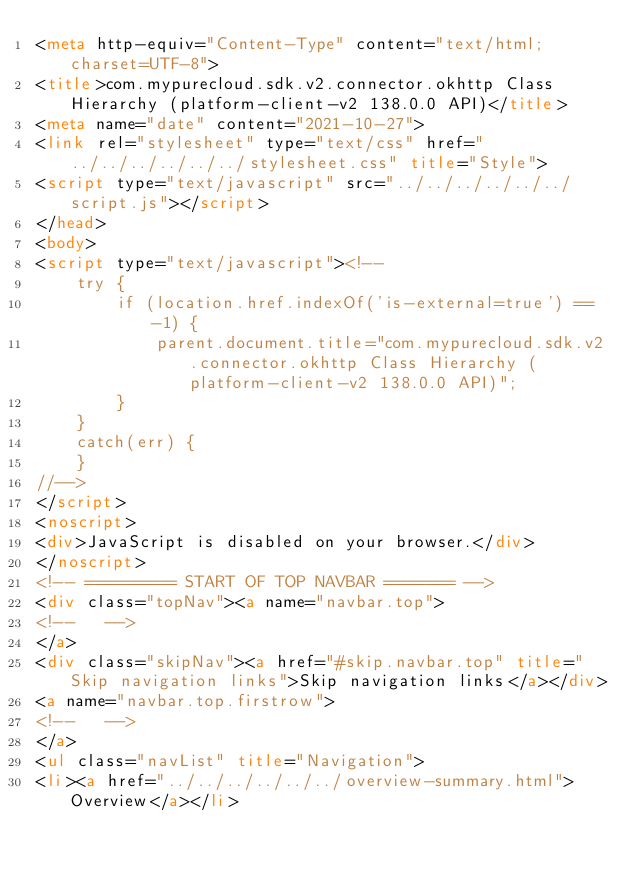<code> <loc_0><loc_0><loc_500><loc_500><_HTML_><meta http-equiv="Content-Type" content="text/html; charset=UTF-8">
<title>com.mypurecloud.sdk.v2.connector.okhttp Class Hierarchy (platform-client-v2 138.0.0 API)</title>
<meta name="date" content="2021-10-27">
<link rel="stylesheet" type="text/css" href="../../../../../../stylesheet.css" title="Style">
<script type="text/javascript" src="../../../../../../script.js"></script>
</head>
<body>
<script type="text/javascript"><!--
    try {
        if (location.href.indexOf('is-external=true') == -1) {
            parent.document.title="com.mypurecloud.sdk.v2.connector.okhttp Class Hierarchy (platform-client-v2 138.0.0 API)";
        }
    }
    catch(err) {
    }
//-->
</script>
<noscript>
<div>JavaScript is disabled on your browser.</div>
</noscript>
<!-- ========= START OF TOP NAVBAR ======= -->
<div class="topNav"><a name="navbar.top">
<!--   -->
</a>
<div class="skipNav"><a href="#skip.navbar.top" title="Skip navigation links">Skip navigation links</a></div>
<a name="navbar.top.firstrow">
<!--   -->
</a>
<ul class="navList" title="Navigation">
<li><a href="../../../../../../overview-summary.html">Overview</a></li></code> 